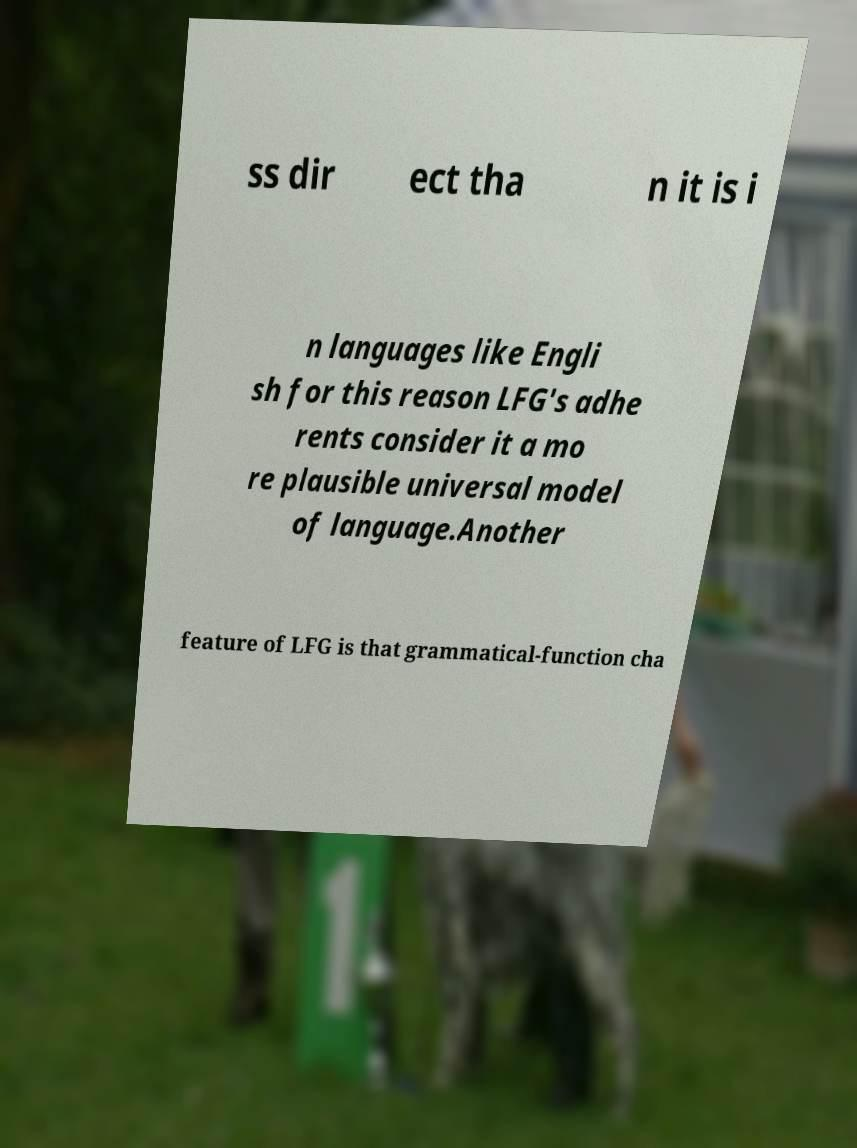Please read and relay the text visible in this image. What does it say? ss dir ect tha n it is i n languages like Engli sh for this reason LFG's adhe rents consider it a mo re plausible universal model of language.Another feature of LFG is that grammatical-function cha 